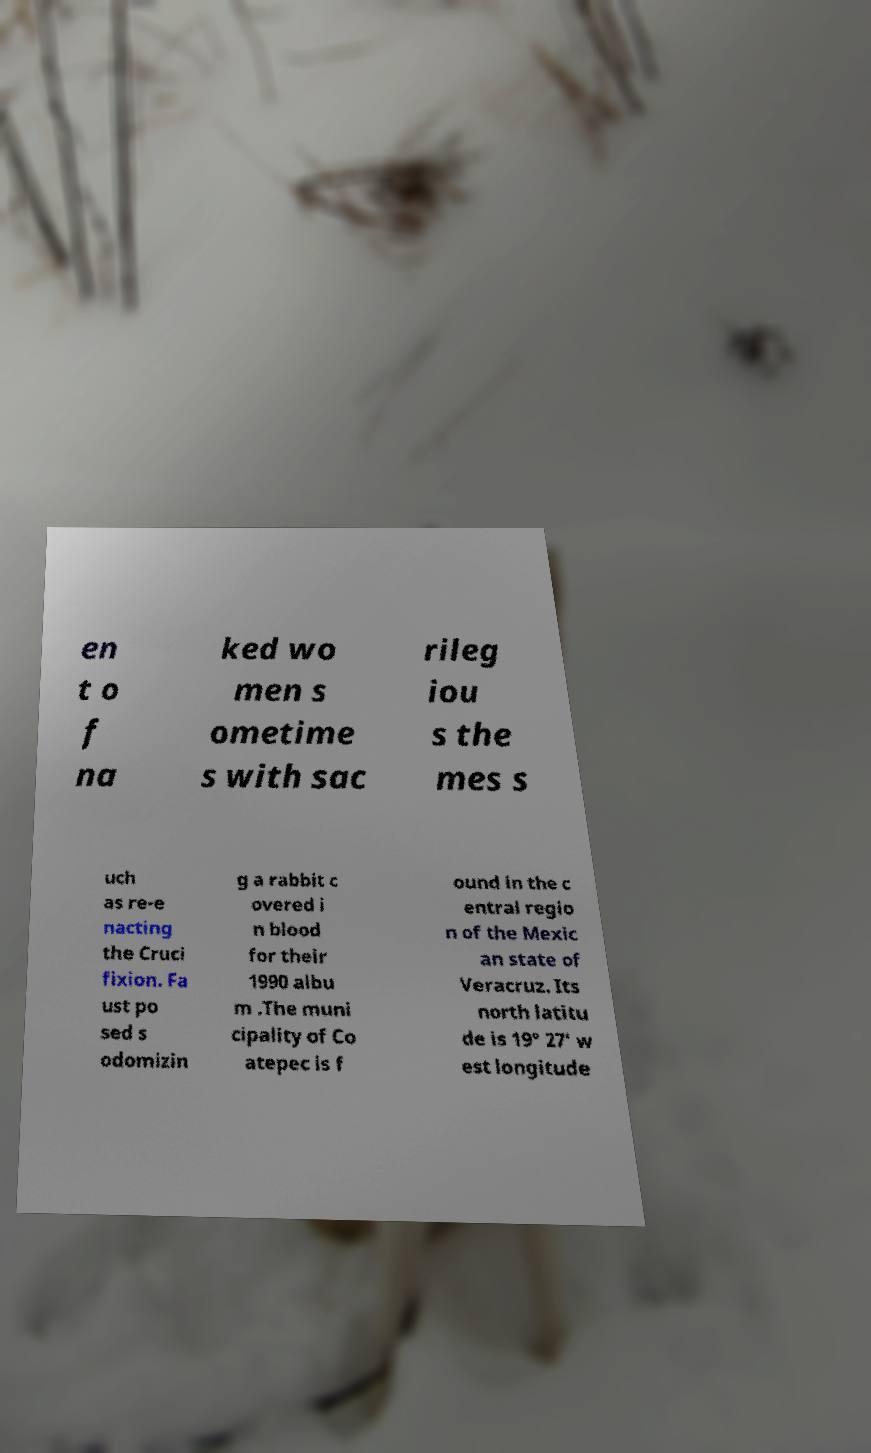There's text embedded in this image that I need extracted. Can you transcribe it verbatim? en t o f na ked wo men s ometime s with sac rileg iou s the mes s uch as re-e nacting the Cruci fixion. Fa ust po sed s odomizin g a rabbit c overed i n blood for their 1990 albu m .The muni cipality of Co atepec is f ound in the c entral regio n of the Mexic an state of Veracruz. Its north latitu de is 19° 27′ w est longitude 